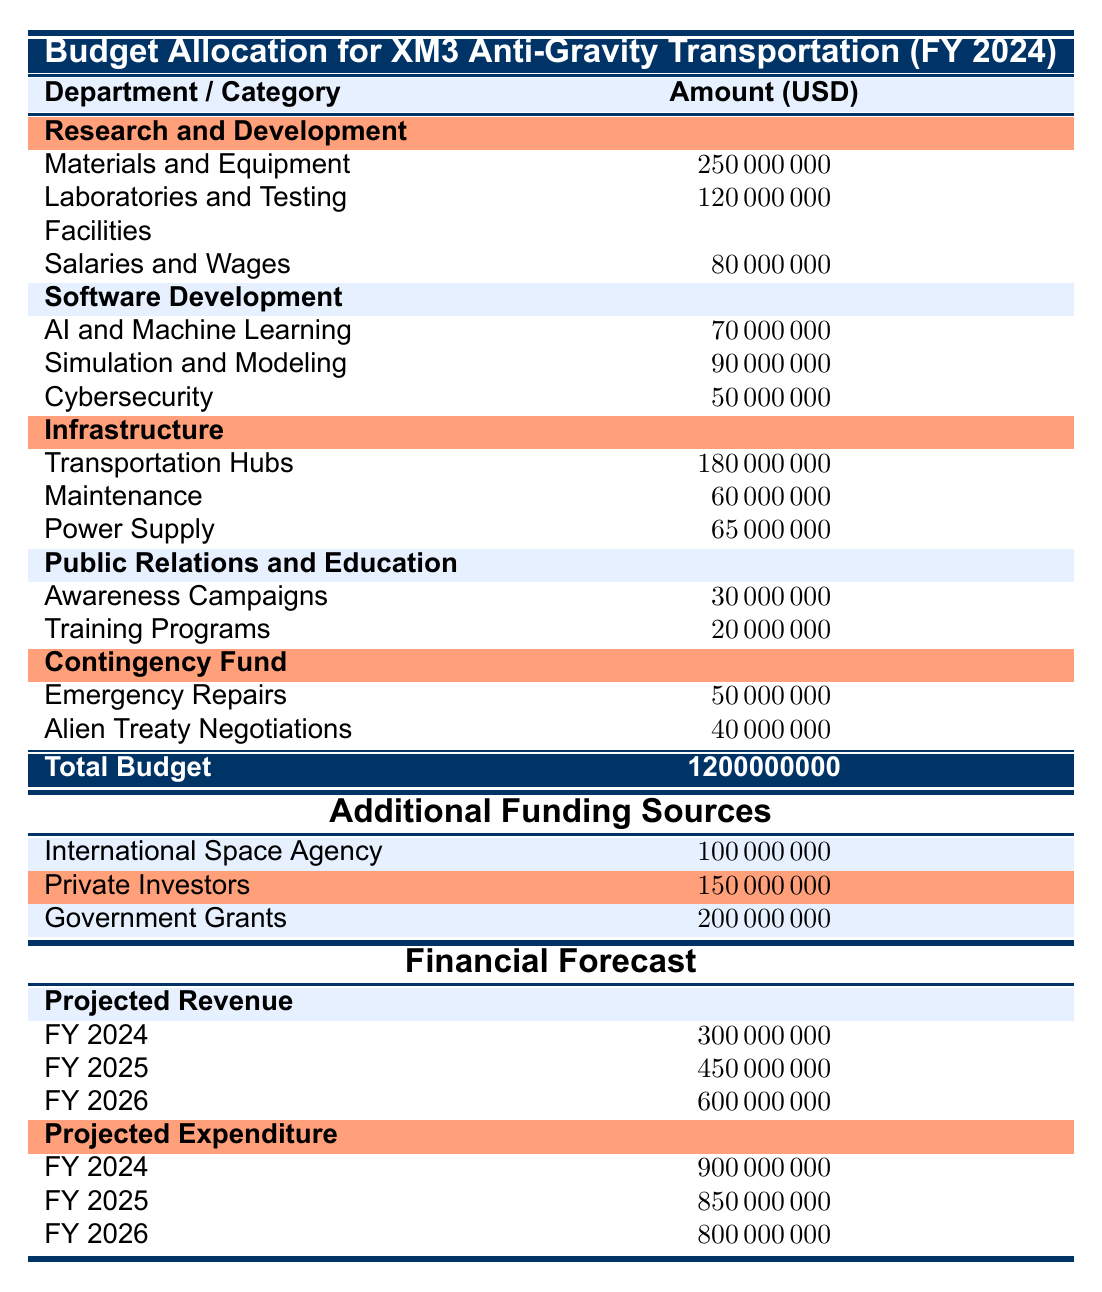What is the total budget allocated for the development of anti-gravity transportation systems? The total budget is specified in the table and is found in the row labeled "Total Budget." The amount listed there is 1,200,000,000 USD.
Answer: 1200000000 Which department has the highest budget allocation for its expenses? By reviewing the budget allocations for each department, we see that the "Research and Development" department has the highest amount, totaling 450,000,000 USD, when adding all its expenses together.
Answer: Research and Development How much funding is expected from private investors? The amount expected from private investors is directly listed in the "Additional Funding Sources" section of the table, which states it is 150,000,000 USD.
Answer: 150000000 What is the total projected revenue for fiscal year 2025? The projected revenue for fiscal year 2025 can be found in the "Projected Revenue" section at 450,000,000 USD according to the data provided.
Answer: 450000000 What percentage of the total budget is allocated to Emergency Repairs? The amount allocated to Emergency Repairs is 50,000,000 USD. To find its percentage of the total budget of 1,200,000,000 USD, we calculate (50,000,000 / 1,200,000,000) * 100 = 4.17%. Thus, approximately 4.17% of the total budget is allocated to Emergency Repairs.
Answer: 4.17% Is the total projected expenditure for fiscal year 2026 less than the projected revenue for the same year? The projected expenditure for fiscal year 2026 is 800,000,000 USD while the projected revenue for the same year is 600,000,000 USD. Since 800,000,000 is greater than 600,000,000, the statement is false.
Answer: No What is the total amount allocated for the salaries and wages of scientists and engineers? The total allocated for salaries and wages is explicitly mentioned in the "Research and Development" department's expenses, totaling 80,000,000 USD.
Answer: 80000000 If we sum the amounts allocated to both the "AI and Machine Learning" and "Simulation and Modeling" categories, what is the total? The "AI and Machine Learning" category has an allocation of 70,000,000 USD and "Simulation and Modeling" has 90,000,000 USD. By adding these two amounts together, we get 70,000,000 + 90,000,000 = 160,000,000 USD for the total.
Answer: 160000000 How much is the combined budget for Training Programs and Awareness Campaigns? The "Training Programs" budget is 20,000,000 USD, and "Awareness Campaigns" leverages 30,000,000 USD. Adding those values gives us 20,000,000 + 30,000,000 = 50,000,000 USD.
Answer: 50000000 